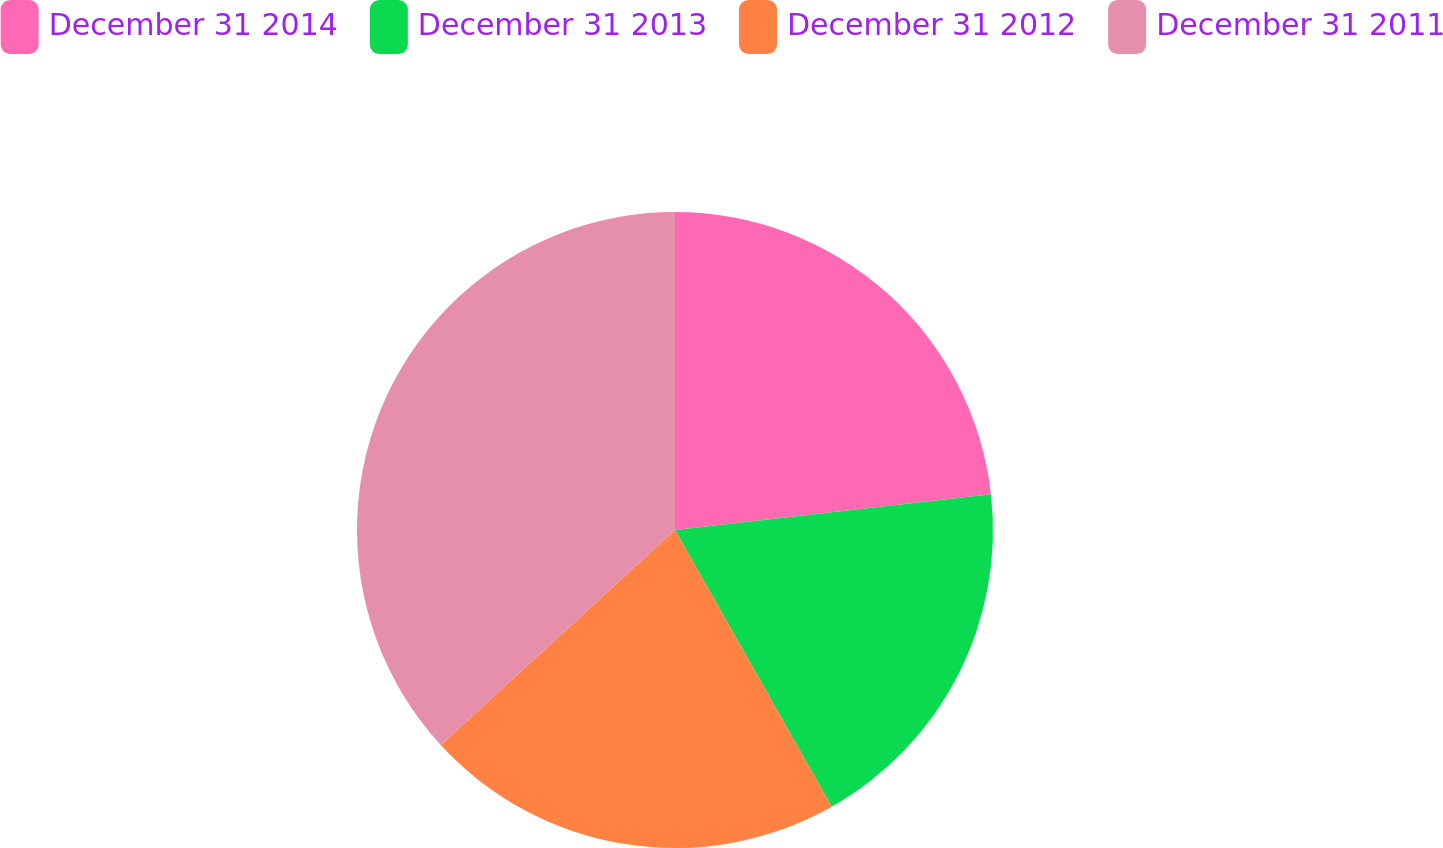Convert chart. <chart><loc_0><loc_0><loc_500><loc_500><pie_chart><fcel>December 31 2014<fcel>December 31 2013<fcel>December 31 2012<fcel>December 31 2011<nl><fcel>23.21%<fcel>18.59%<fcel>21.38%<fcel>36.82%<nl></chart> 